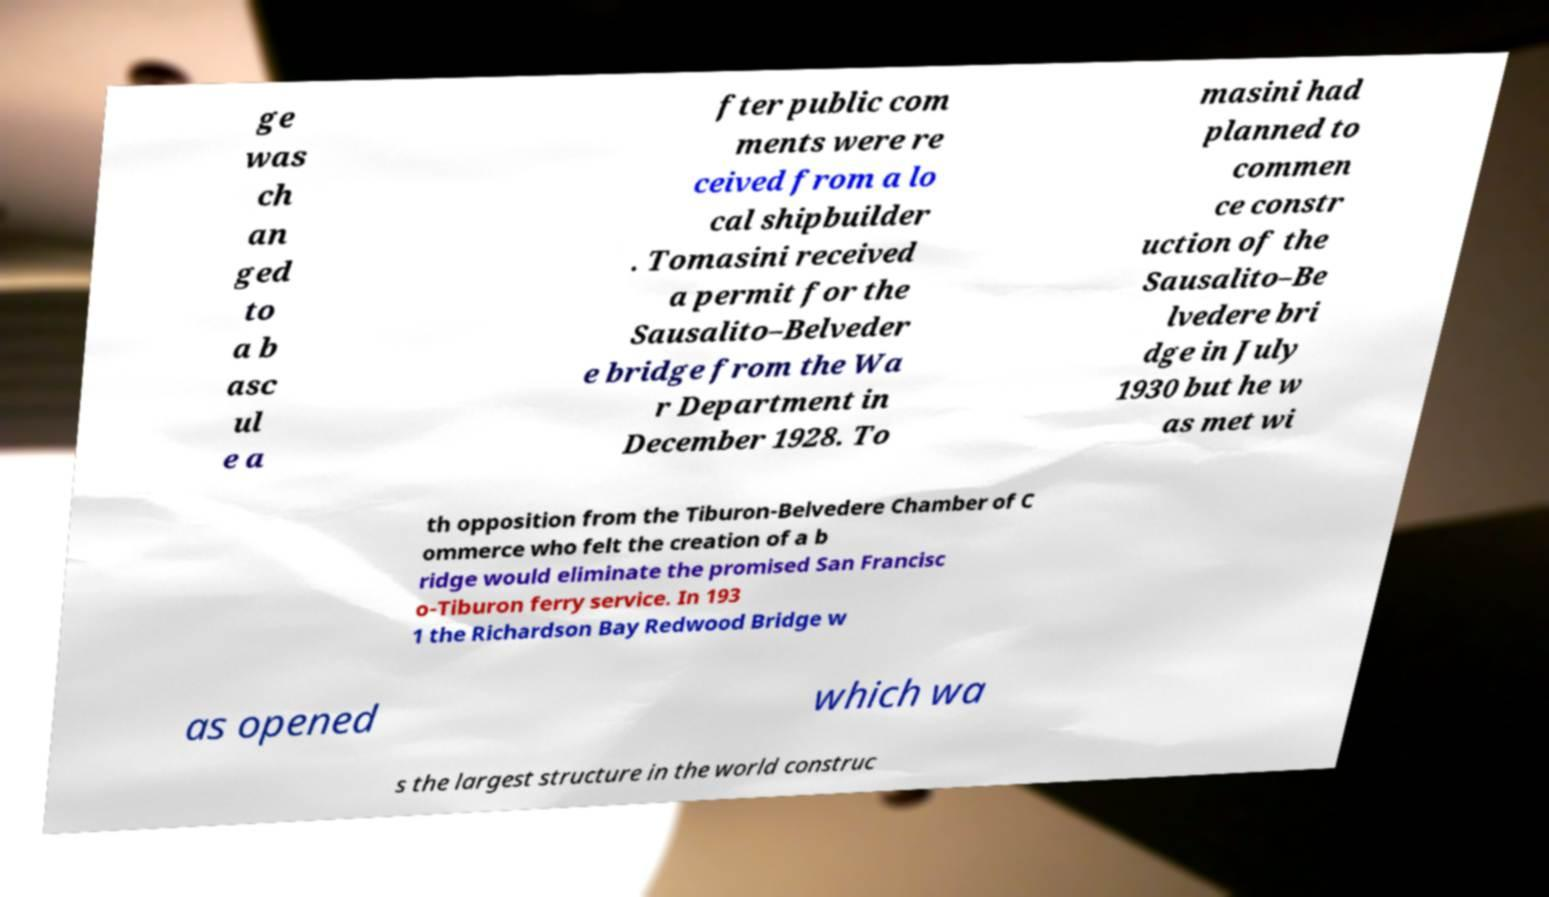Please identify and transcribe the text found in this image. ge was ch an ged to a b asc ul e a fter public com ments were re ceived from a lo cal shipbuilder . Tomasini received a permit for the Sausalito–Belveder e bridge from the Wa r Department in December 1928. To masini had planned to commen ce constr uction of the Sausalito–Be lvedere bri dge in July 1930 but he w as met wi th opposition from the Tiburon-Belvedere Chamber of C ommerce who felt the creation of a b ridge would eliminate the promised San Francisc o-Tiburon ferry service. In 193 1 the Richardson Bay Redwood Bridge w as opened which wa s the largest structure in the world construc 